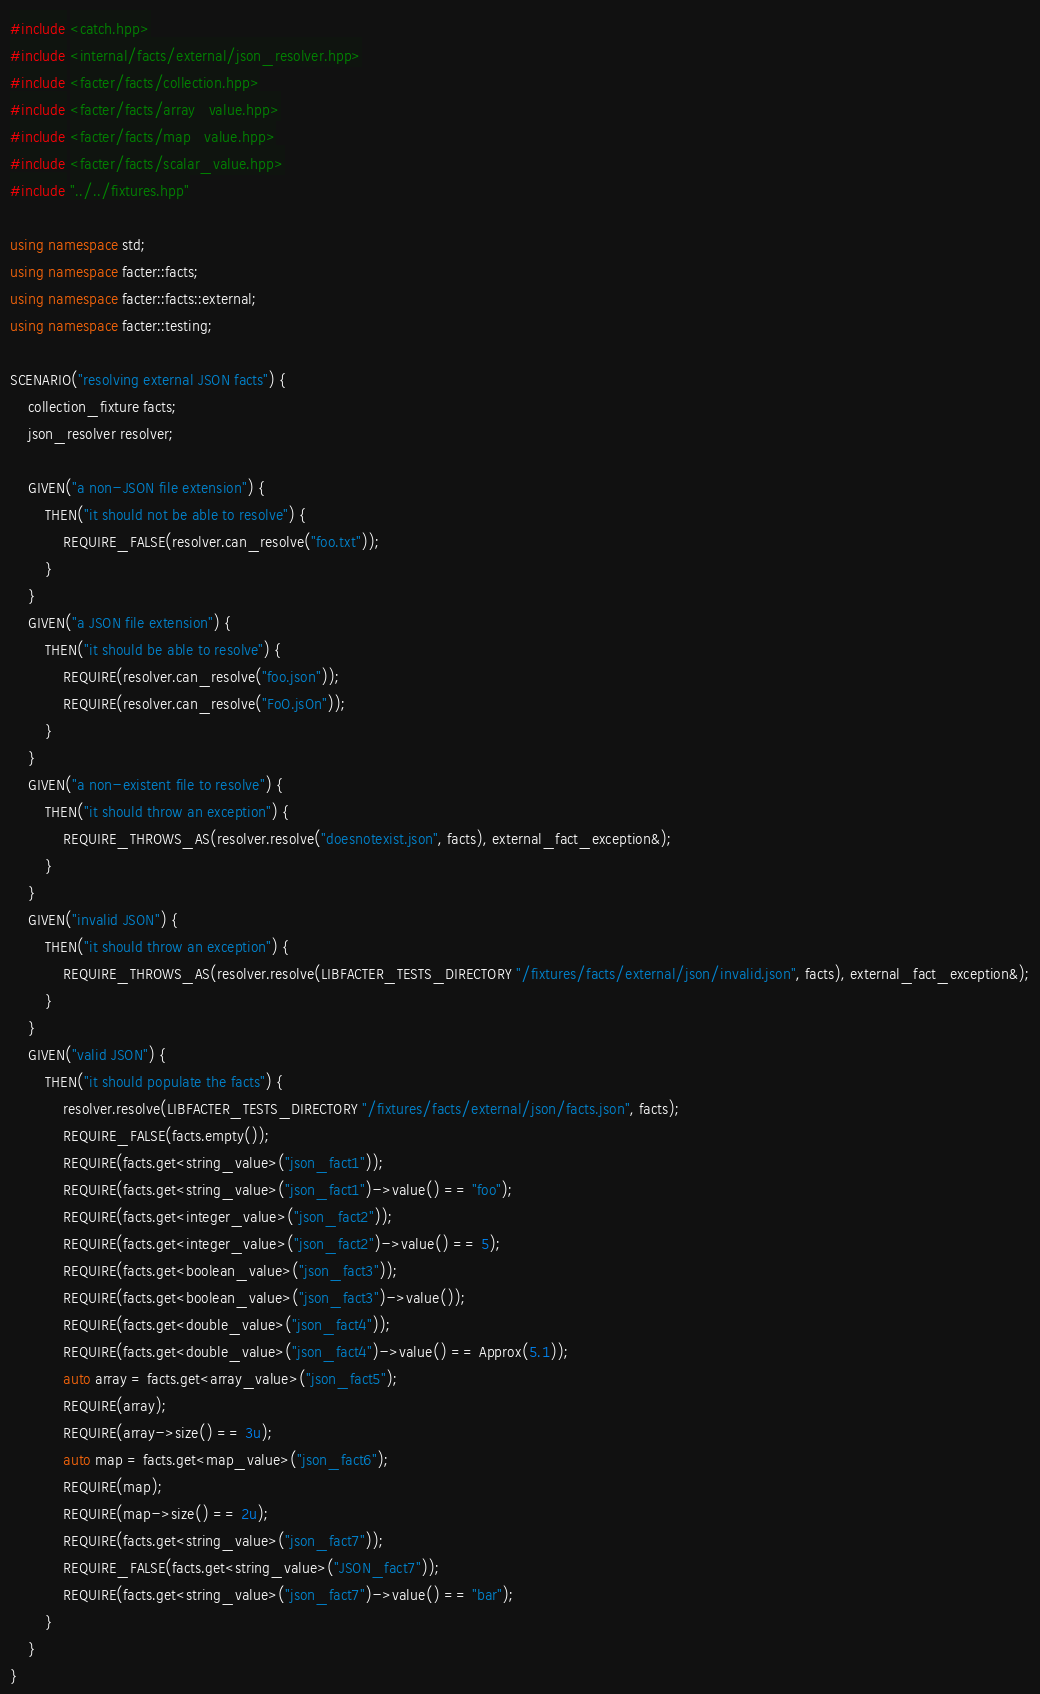Convert code to text. <code><loc_0><loc_0><loc_500><loc_500><_C++_>#include <catch.hpp>
#include <internal/facts/external/json_resolver.hpp>
#include <facter/facts/collection.hpp>
#include <facter/facts/array_value.hpp>
#include <facter/facts/map_value.hpp>
#include <facter/facts/scalar_value.hpp>
#include "../../fixtures.hpp"

using namespace std;
using namespace facter::facts;
using namespace facter::facts::external;
using namespace facter::testing;

SCENARIO("resolving external JSON facts") {
    collection_fixture facts;
    json_resolver resolver;

    GIVEN("a non-JSON file extension") {
        THEN("it should not be able to resolve") {
            REQUIRE_FALSE(resolver.can_resolve("foo.txt"));
        }
    }
    GIVEN("a JSON file extension") {
        THEN("it should be able to resolve") {
            REQUIRE(resolver.can_resolve("foo.json"));
            REQUIRE(resolver.can_resolve("FoO.jsOn"));
        }
    }
    GIVEN("a non-existent file to resolve") {
        THEN("it should throw an exception") {
            REQUIRE_THROWS_AS(resolver.resolve("doesnotexist.json", facts), external_fact_exception&);
        }
    }
    GIVEN("invalid JSON") {
        THEN("it should throw an exception") {
            REQUIRE_THROWS_AS(resolver.resolve(LIBFACTER_TESTS_DIRECTORY "/fixtures/facts/external/json/invalid.json", facts), external_fact_exception&);
        }
    }
    GIVEN("valid JSON") {
        THEN("it should populate the facts") {
            resolver.resolve(LIBFACTER_TESTS_DIRECTORY "/fixtures/facts/external/json/facts.json", facts);
            REQUIRE_FALSE(facts.empty());
            REQUIRE(facts.get<string_value>("json_fact1"));
            REQUIRE(facts.get<string_value>("json_fact1")->value() == "foo");
            REQUIRE(facts.get<integer_value>("json_fact2"));
            REQUIRE(facts.get<integer_value>("json_fact2")->value() == 5);
            REQUIRE(facts.get<boolean_value>("json_fact3"));
            REQUIRE(facts.get<boolean_value>("json_fact3")->value());
            REQUIRE(facts.get<double_value>("json_fact4"));
            REQUIRE(facts.get<double_value>("json_fact4")->value() == Approx(5.1));
            auto array = facts.get<array_value>("json_fact5");
            REQUIRE(array);
            REQUIRE(array->size() == 3u);
            auto map = facts.get<map_value>("json_fact6");
            REQUIRE(map);
            REQUIRE(map->size() == 2u);
            REQUIRE(facts.get<string_value>("json_fact7"));
            REQUIRE_FALSE(facts.get<string_value>("JSON_fact7"));
            REQUIRE(facts.get<string_value>("json_fact7")->value() == "bar");
        }
    }
}
</code> 